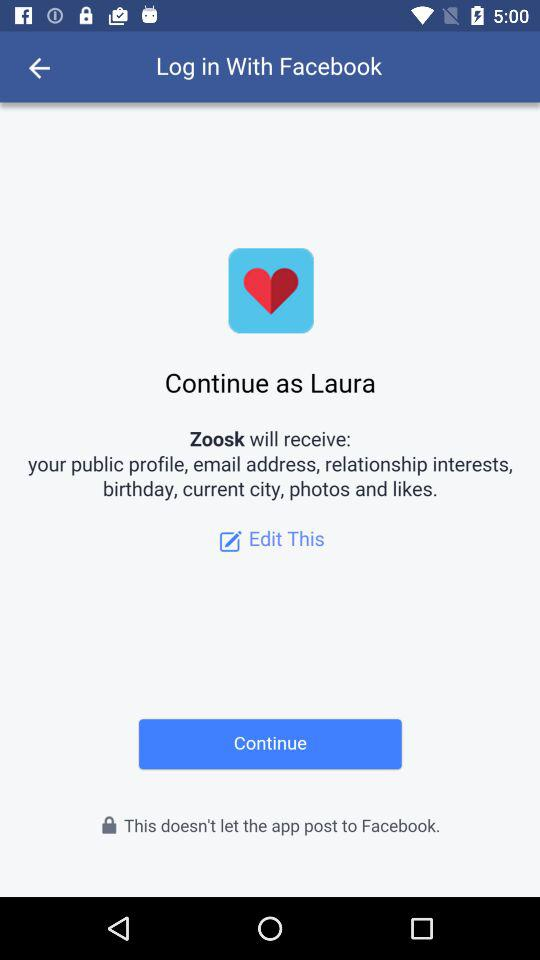What application is asking for permission? The application asking for permission is "Zoosk". 